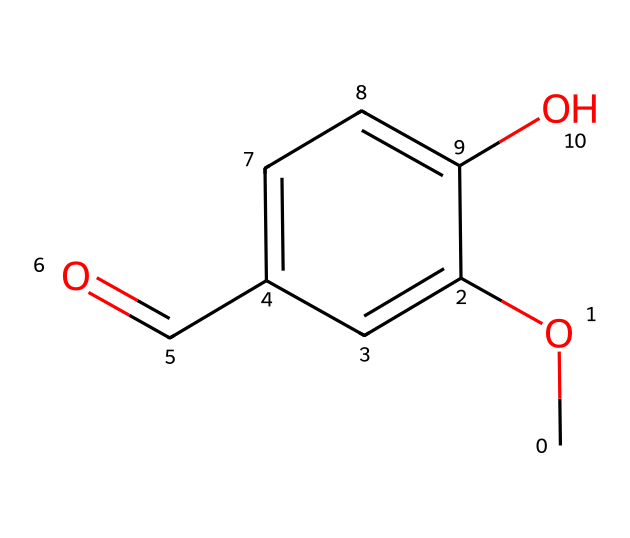What type of chemical is represented here? This chemical has a carbonyl group (C=O) and a hydroxyl group (–OH), indicating it is an aldehyde due to the presence of the carbonyl at the end of the carbon chain.
Answer: aldehyde How many carbon atoms are in vanillin? By analyzing the SMILES representation, there are six carbon atoms represented (C).
Answer: six What functional groups are present in vanillin? The SMILES shows a methoxy (–OCH3), an aldehyde (–CHO), and a hydroxyl (–OH) group, all of which are characteristic of the functional groups in vanillin.
Answer: methoxy, aldehyde, hydroxyl What is the molecular formula of vanillin? By counting the atoms represented in the SMILES, vanillin has a molecular formula of C8H8O3, indicating a total of 8 carbons, 8 hydrogens, and 3 oxygens.
Answer: C8H8O3 What part of the molecule signifies its aldehyde nature? The carbonyl (C=O) group at the end of the carbon chain indicates that this molecule is an aldehyde.
Answer: carbonyl group What is the significance of the hydroxyl group in vanillin? The hydroxyl group (–OH) contributes to the solubility and flavor profile of vanillin, enhancing its sweetness and making it an important component in flavoring.
Answer: flavor enhancement 